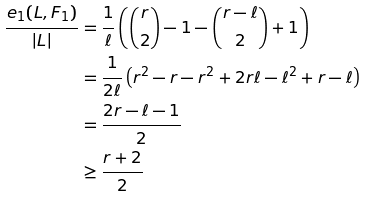<formula> <loc_0><loc_0><loc_500><loc_500>\frac { e _ { 1 } ( L , F _ { 1 } ) } { | L | } & = \frac { 1 } { \ell } \left ( \binom { r } { 2 } - 1 - \binom { r - \ell } { 2 } + 1 \right ) \\ & = \frac { 1 } { 2 \ell } \left ( r ^ { 2 } - r - r ^ { 2 } + 2 r \ell - \ell ^ { 2 } + r - \ell \right ) \\ & = \frac { 2 r - \ell - 1 } { 2 } \\ & \geq \frac { r + 2 } { 2 }</formula> 